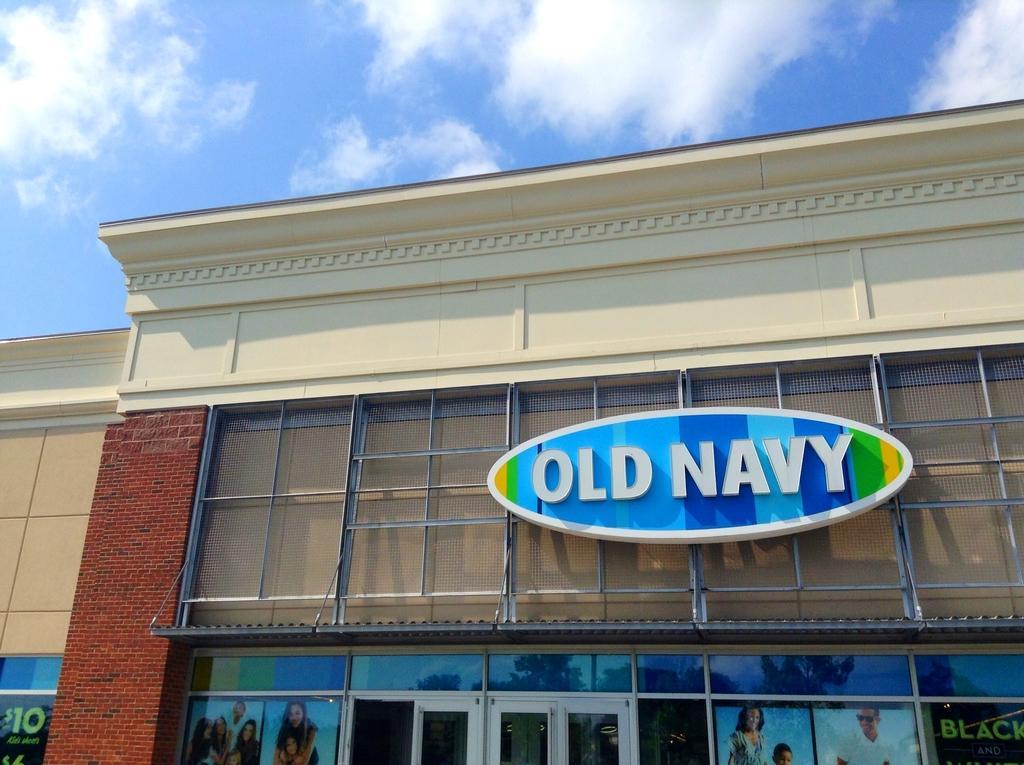In one or two sentences, can you explain what this image depicts? In this image we can see sky with clouds, buildings, name board and advertisements on the mirrors. 